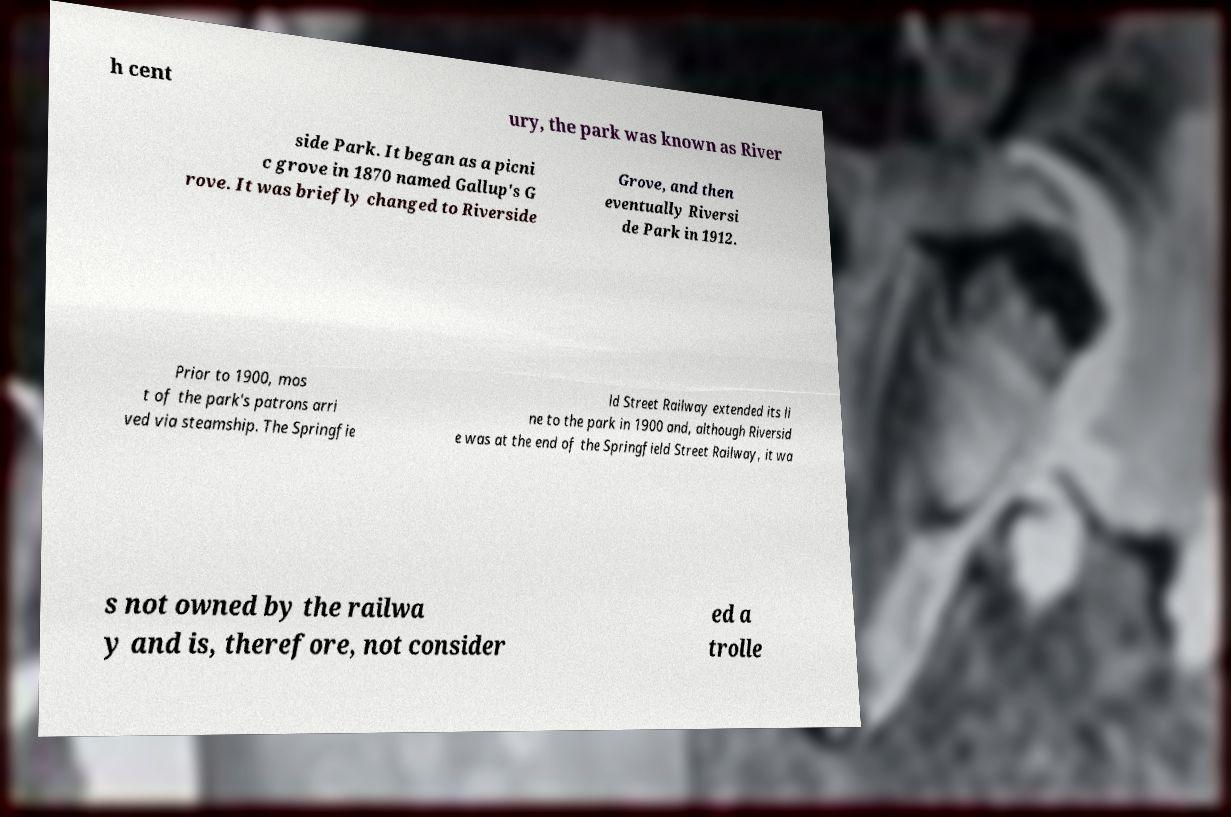Please identify and transcribe the text found in this image. h cent ury, the park was known as River side Park. It began as a picni c grove in 1870 named Gallup's G rove. It was briefly changed to Riverside Grove, and then eventually Riversi de Park in 1912. Prior to 1900, mos t of the park's patrons arri ved via steamship. The Springfie ld Street Railway extended its li ne to the park in 1900 and, although Riversid e was at the end of the Springfield Street Railway, it wa s not owned by the railwa y and is, therefore, not consider ed a trolle 